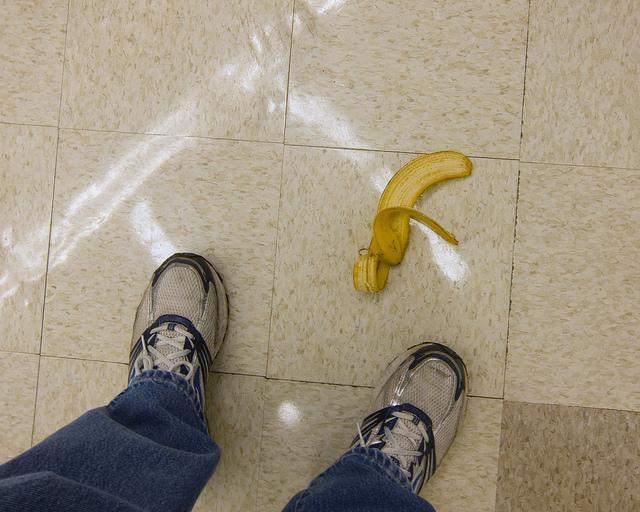How many bananas are in the picture?
Give a very brief answer. 1. How many people are wearing skis in this image?
Give a very brief answer. 0. 